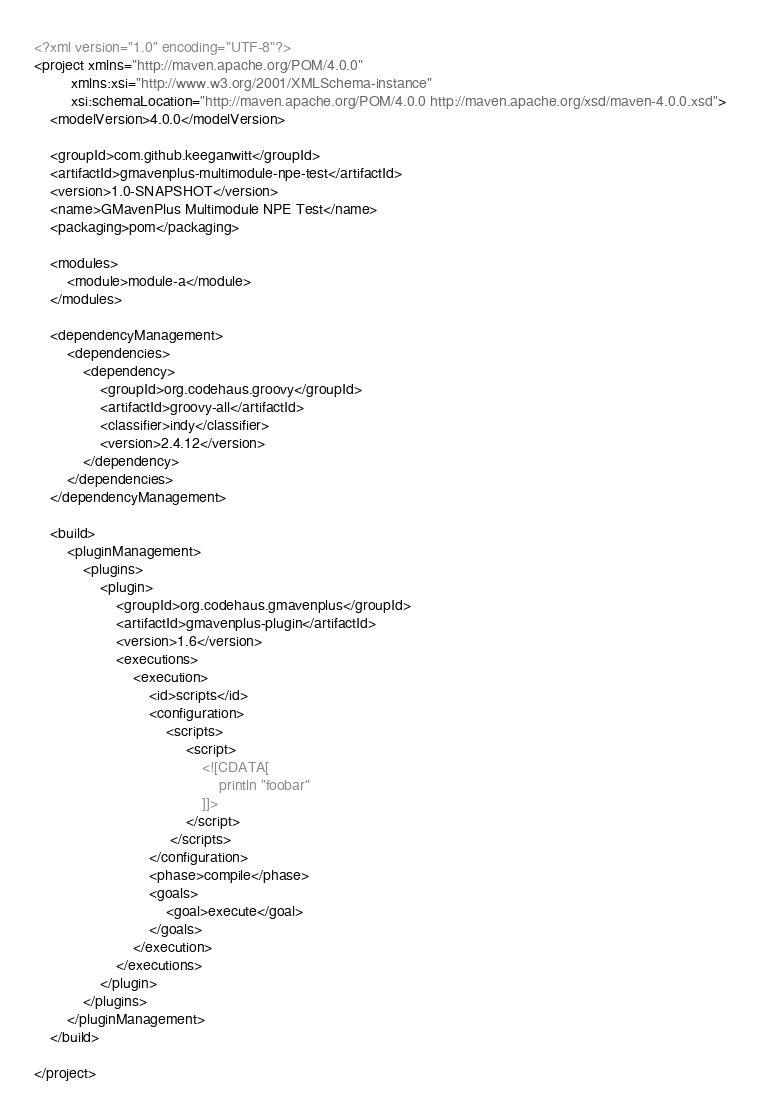Convert code to text. <code><loc_0><loc_0><loc_500><loc_500><_XML_><?xml version="1.0" encoding="UTF-8"?>
<project xmlns="http://maven.apache.org/POM/4.0.0"
         xmlns:xsi="http://www.w3.org/2001/XMLSchema-instance"
         xsi:schemaLocation="http://maven.apache.org/POM/4.0.0 http://maven.apache.org/xsd/maven-4.0.0.xsd">
    <modelVersion>4.0.0</modelVersion>

    <groupId>com.github.keeganwitt</groupId>
    <artifactId>gmavenplus-multimodule-npe-test</artifactId>
    <version>1.0-SNAPSHOT</version>
    <name>GMavenPlus Multimodule NPE Test</name>
    <packaging>pom</packaging>

    <modules>
        <module>module-a</module>
    </modules>

    <dependencyManagement>
        <dependencies>
            <dependency>
                <groupId>org.codehaus.groovy</groupId>
                <artifactId>groovy-all</artifactId>
                <classifier>indy</classifier>
                <version>2.4.12</version>
            </dependency>
        </dependencies>
    </dependencyManagement>

    <build>
        <pluginManagement>
            <plugins>
                <plugin>
                    <groupId>org.codehaus.gmavenplus</groupId>
                    <artifactId>gmavenplus-plugin</artifactId>
                    <version>1.6</version>
                    <executions>
                        <execution>
                            <id>scripts</id>
                            <configuration>
                                <scripts>
                                     <script>
                                         <![CDATA[
                                             println "foobar"
                                         ]]>
                                     </script>
                                 </scripts>
                            </configuration>
                            <phase>compile</phase>
                            <goals>
                                <goal>execute</goal>
                            </goals>
                        </execution>
                    </executions>
                </plugin>
            </plugins>
        </pluginManagement>
    </build>

</project>
</code> 